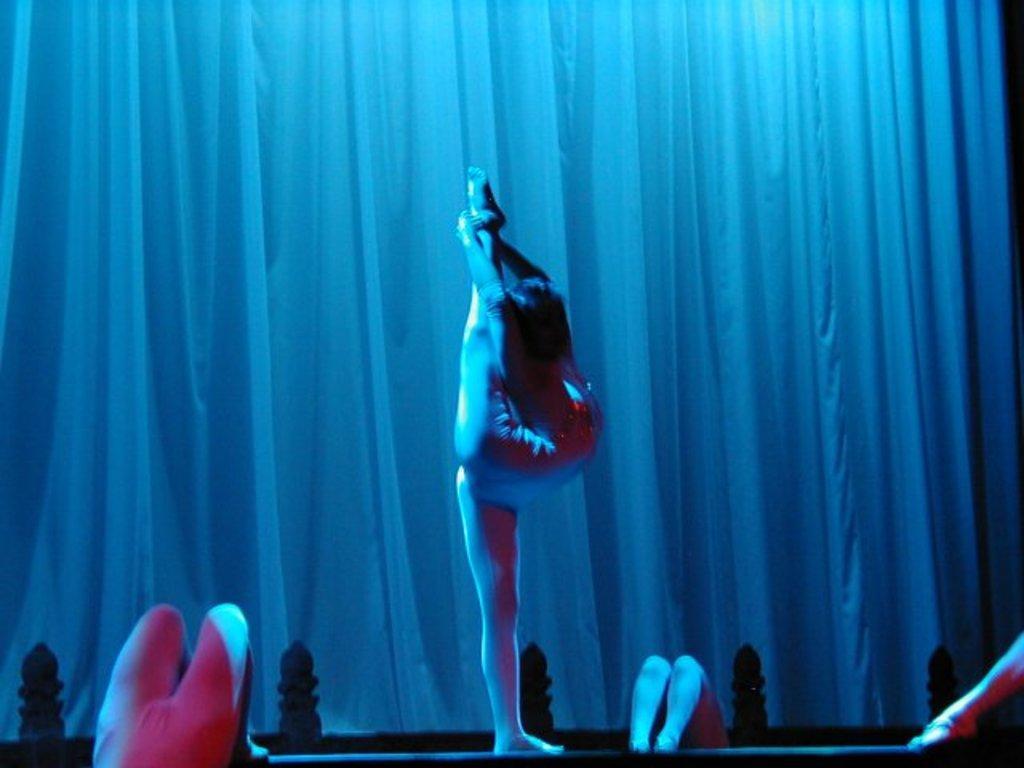Describe this image in one or two sentences. In the center of the image we can see people performing gymnastics. In the background there is a curtain. 